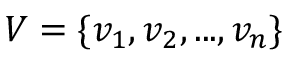<formula> <loc_0><loc_0><loc_500><loc_500>V = \{ v _ { 1 } , v _ { 2 } , \dots , v _ { n } \}</formula> 